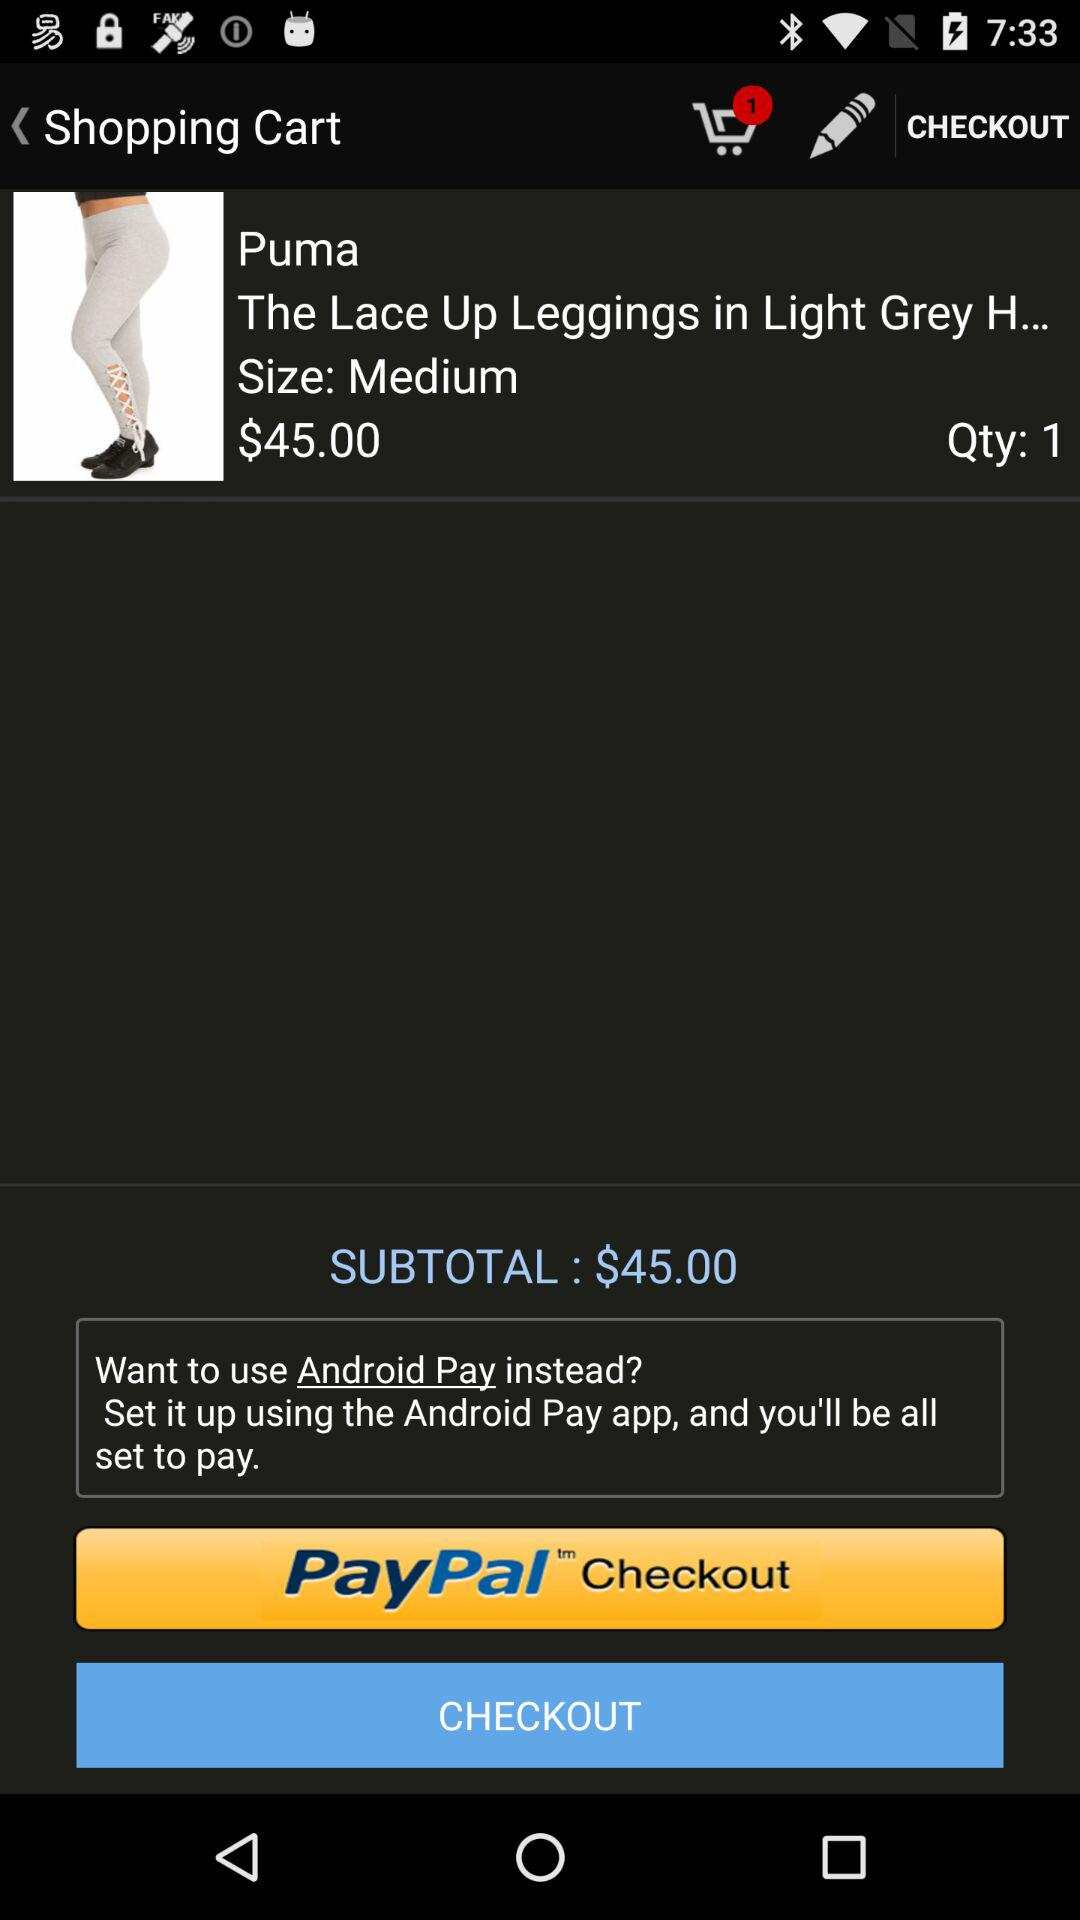What is the size? The size is medium. 